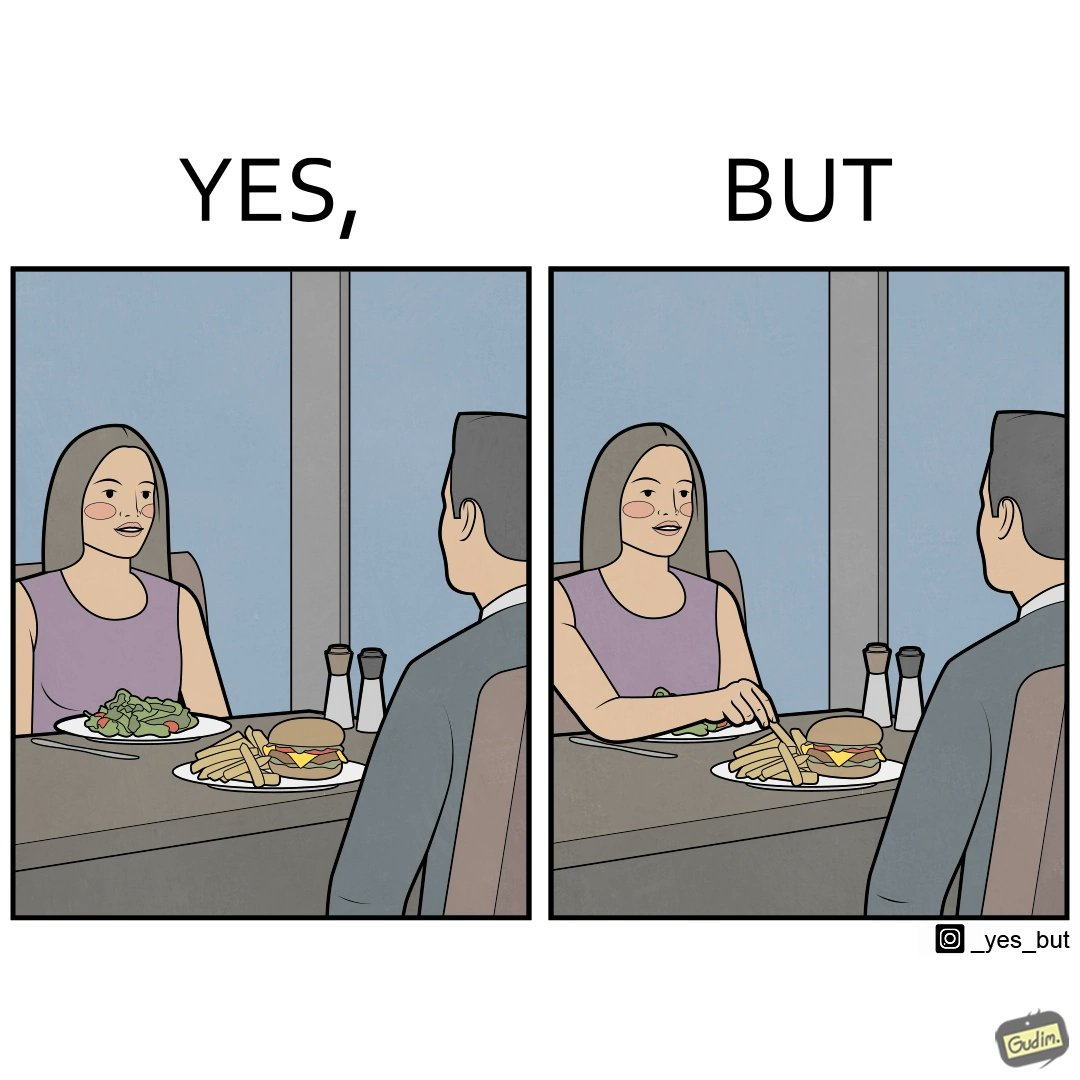Provide a description of this image. The image is ironic because in the first image it is shown that the woman has got salad for her but she is having french fries from the man's plate which displays that the girl is trying to show herself as health conscious by having a plate of salad for her but she wants to have to have fast food but rather than having them for herself she is taking some from other's plate 